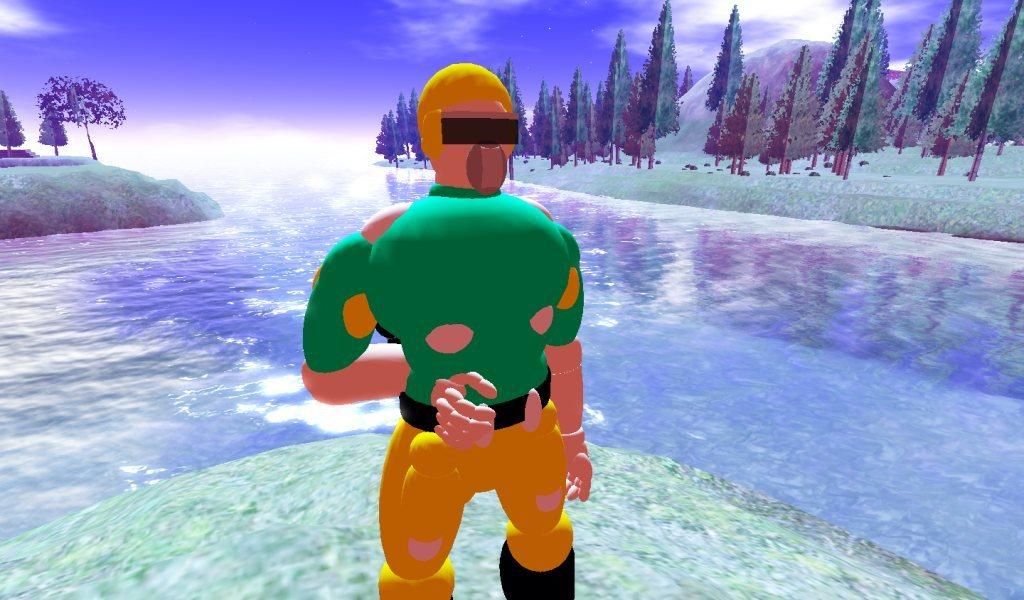What type of image is being described? The image is animated. Can you describe the person in the image? There is a person in the image. What is the setting of the image? There is water and many trees in the image, and the sky and clouds are visible in the background. What type of pie is being baked in the image? There is no pie present in the image; it features an animated person in a setting with water, trees, sky, and clouds. 